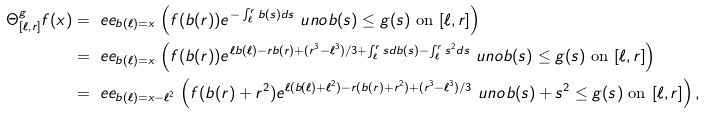<formula> <loc_0><loc_0><loc_500><loc_500>\Theta ^ { g } _ { [ \ell , r ] } f ( x ) & = \ e e _ { b ( \ell ) = x } \, \left ( f ( b ( r ) ) e ^ { - \int _ { \ell } ^ { r } b ( s ) d s } \ u n o { b ( s ) \leq g ( s ) \text { on } [ \ell , r ] } \right ) \\ & = \ e e _ { b ( \ell ) = x } \, \left ( f ( b ( r ) ) e ^ { \ell b ( \ell ) - r b ( r ) + ( r ^ { 3 } - \ell ^ { 3 } ) / 3 + \int _ { \ell } ^ { r } s d b ( s ) - \int _ { \ell } ^ { r } s ^ { 2 } d s } \ u n o { b ( s ) \leq g ( s ) \text { on } [ \ell , r ] } \right ) \\ & = \ e e _ { b ( \ell ) = x - \ell ^ { 2 } } \, \left ( f ( b ( r ) + r ^ { 2 } ) e ^ { \ell ( b ( \ell ) + \ell ^ { 2 } ) - r ( b ( r ) + r ^ { 2 } ) + ( r ^ { 3 } - \ell ^ { 3 } ) / 3 } \ u n o { b ( s ) + s ^ { 2 } \leq g ( s ) \text { on } [ \ell , r ] } \right ) ,</formula> 